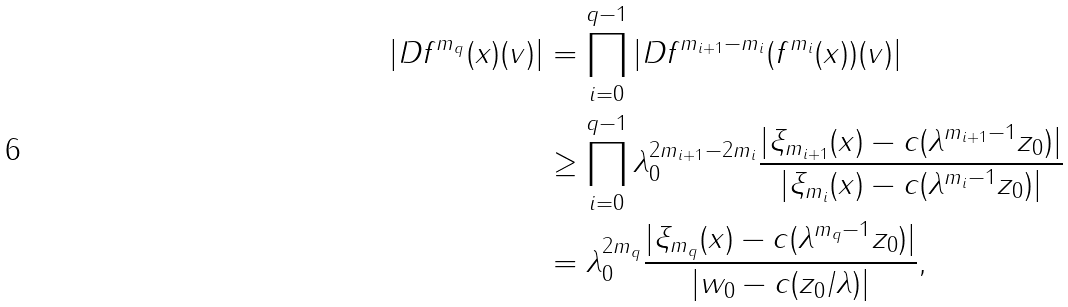Convert formula to latex. <formula><loc_0><loc_0><loc_500><loc_500>| D f ^ { m _ { q } } ( x ) ( v ) | & = \prod _ { i = 0 } ^ { q - 1 } | D f ^ { m _ { i + 1 } - m _ { i } } ( f ^ { m _ { i } } ( x ) ) ( v ) | \\ & \geq \prod _ { i = 0 } ^ { q - 1 } \lambda _ { 0 } ^ { 2 m _ { i + 1 } - 2 m _ { i } } \frac { | \xi _ { m _ { i + 1 } } ( x ) - c ( \lambda ^ { m _ { i + 1 } - 1 } z _ { 0 } ) | } { | \xi _ { m _ { i } } ( x ) - c ( \lambda ^ { m _ { i } - 1 } z _ { 0 } ) | } \\ & = \lambda _ { 0 } ^ { 2 m _ { q } } \frac { | \xi _ { m _ { q } } ( x ) - c ( \lambda ^ { m _ { q } - 1 } z _ { 0 } ) | } { | w _ { 0 } - c ( z _ { 0 } / \lambda ) | } ,</formula> 